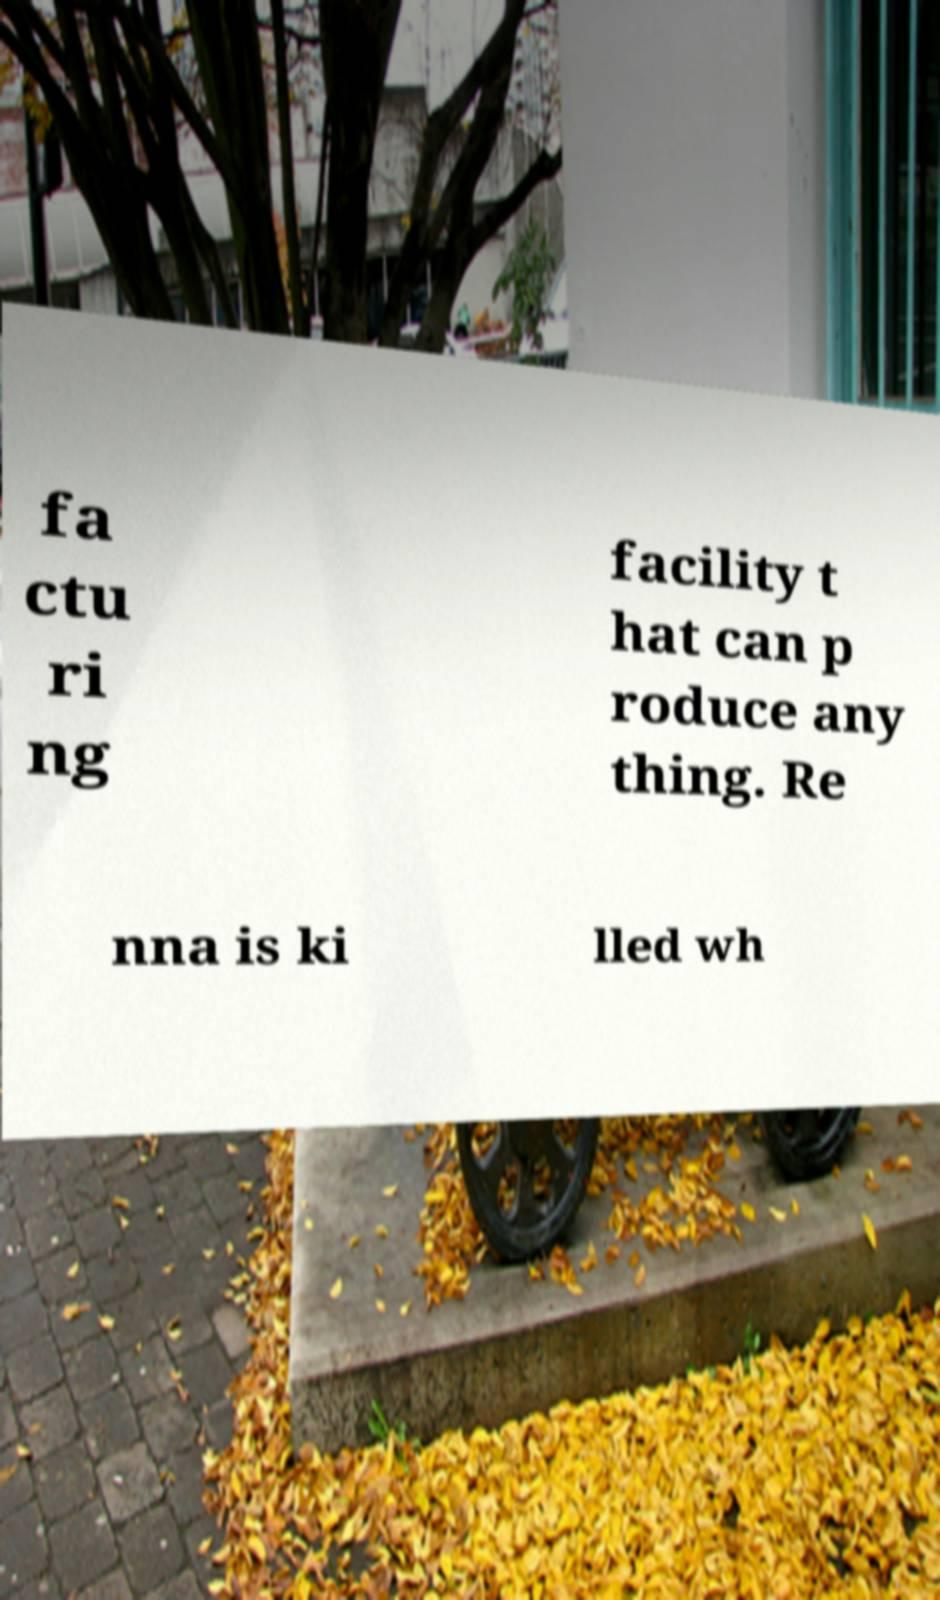Could you assist in decoding the text presented in this image and type it out clearly? fa ctu ri ng facility t hat can p roduce any thing. Re nna is ki lled wh 